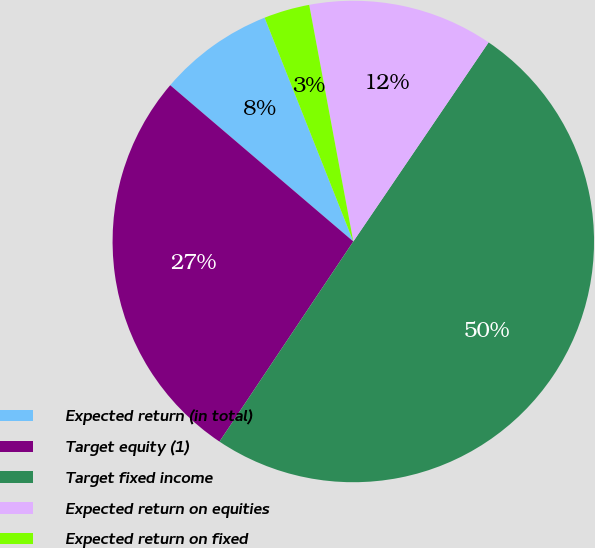Convert chart. <chart><loc_0><loc_0><loc_500><loc_500><pie_chart><fcel>Expected return (in total)<fcel>Target equity (1)<fcel>Target fixed income<fcel>Expected return on equities<fcel>Expected return on fixed<nl><fcel>7.75%<fcel>26.86%<fcel>49.88%<fcel>12.43%<fcel>3.07%<nl></chart> 